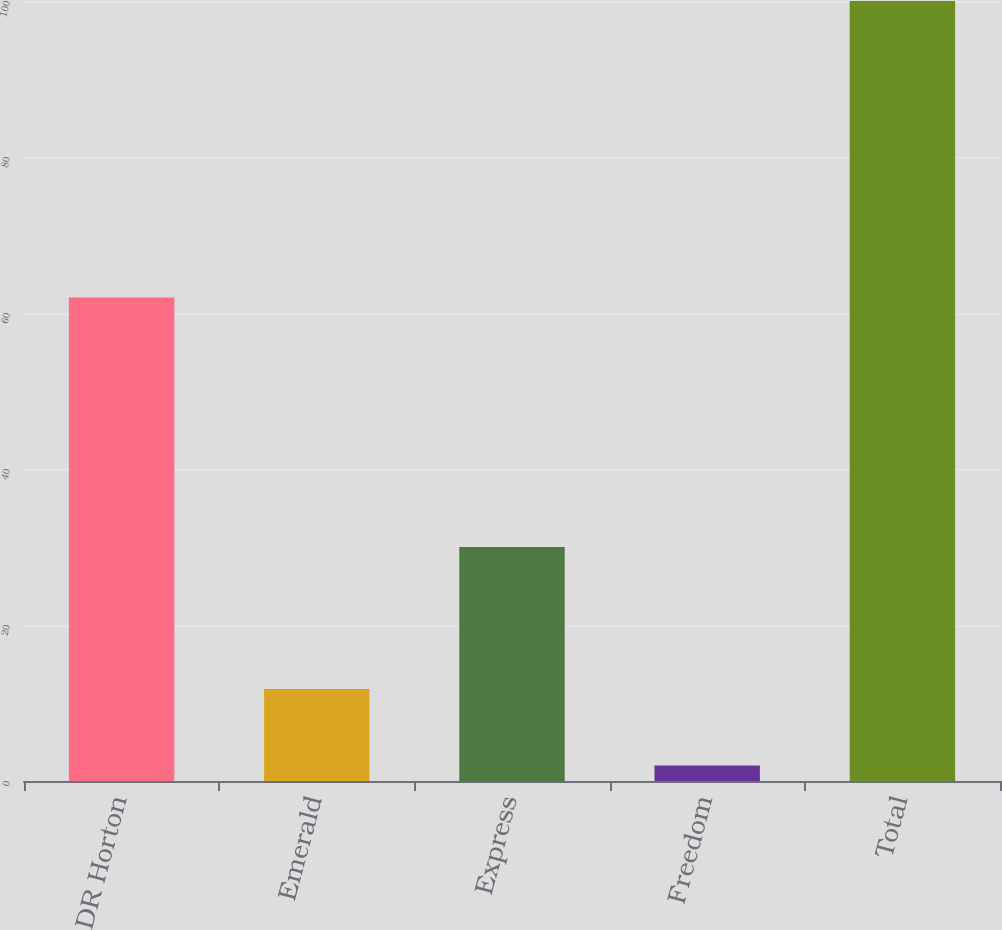<chart> <loc_0><loc_0><loc_500><loc_500><bar_chart><fcel>DR Horton<fcel>Emerald<fcel>Express<fcel>Freedom<fcel>Total<nl><fcel>62<fcel>11.8<fcel>30<fcel>2<fcel>100<nl></chart> 